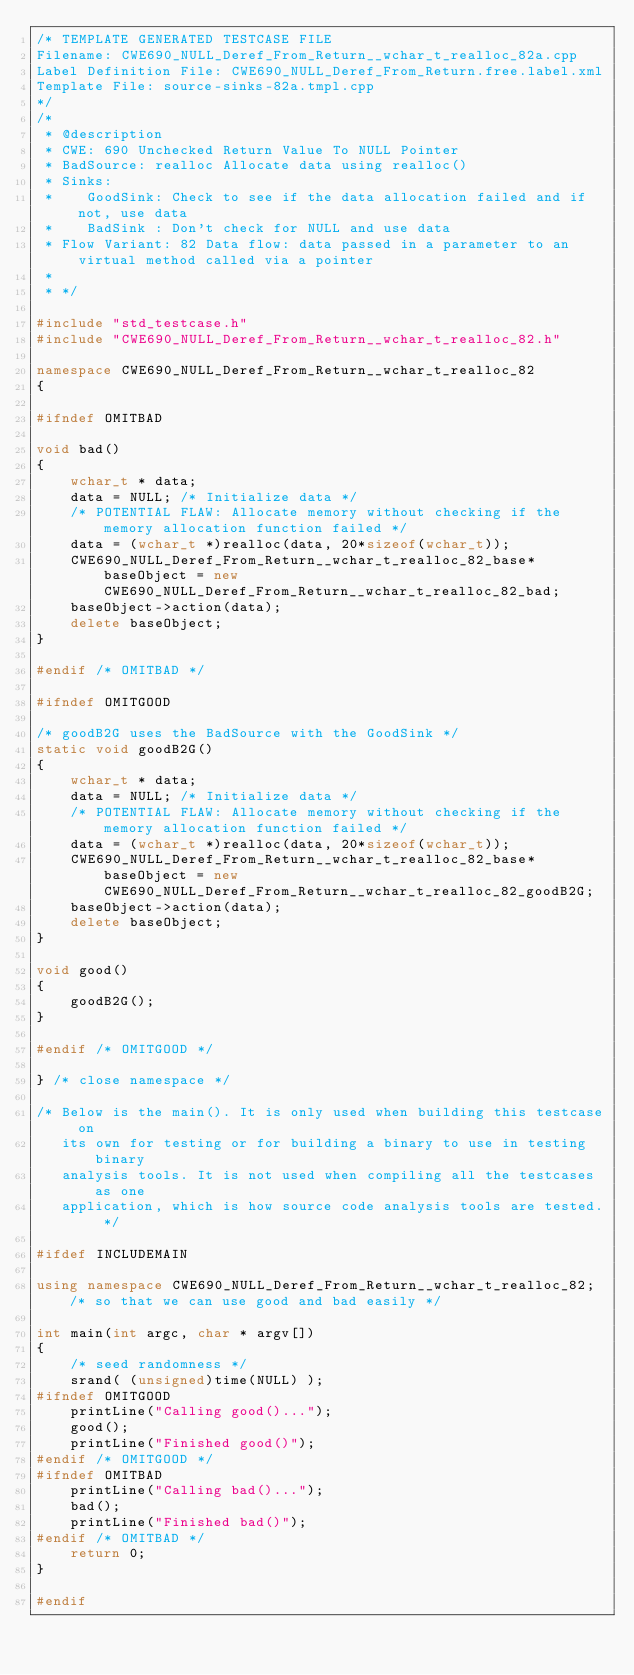<code> <loc_0><loc_0><loc_500><loc_500><_C++_>/* TEMPLATE GENERATED TESTCASE FILE
Filename: CWE690_NULL_Deref_From_Return__wchar_t_realloc_82a.cpp
Label Definition File: CWE690_NULL_Deref_From_Return.free.label.xml
Template File: source-sinks-82a.tmpl.cpp
*/
/*
 * @description
 * CWE: 690 Unchecked Return Value To NULL Pointer
 * BadSource: realloc Allocate data using realloc()
 * Sinks:
 *    GoodSink: Check to see if the data allocation failed and if not, use data
 *    BadSink : Don't check for NULL and use data
 * Flow Variant: 82 Data flow: data passed in a parameter to an virtual method called via a pointer
 *
 * */

#include "std_testcase.h"
#include "CWE690_NULL_Deref_From_Return__wchar_t_realloc_82.h"

namespace CWE690_NULL_Deref_From_Return__wchar_t_realloc_82
{

#ifndef OMITBAD

void bad()
{
    wchar_t * data;
    data = NULL; /* Initialize data */
    /* POTENTIAL FLAW: Allocate memory without checking if the memory allocation function failed */
    data = (wchar_t *)realloc(data, 20*sizeof(wchar_t));
    CWE690_NULL_Deref_From_Return__wchar_t_realloc_82_base* baseObject = new CWE690_NULL_Deref_From_Return__wchar_t_realloc_82_bad;
    baseObject->action(data);
    delete baseObject;
}

#endif /* OMITBAD */

#ifndef OMITGOOD

/* goodB2G uses the BadSource with the GoodSink */
static void goodB2G()
{
    wchar_t * data;
    data = NULL; /* Initialize data */
    /* POTENTIAL FLAW: Allocate memory without checking if the memory allocation function failed */
    data = (wchar_t *)realloc(data, 20*sizeof(wchar_t));
    CWE690_NULL_Deref_From_Return__wchar_t_realloc_82_base* baseObject = new CWE690_NULL_Deref_From_Return__wchar_t_realloc_82_goodB2G;
    baseObject->action(data);
    delete baseObject;
}

void good()
{
    goodB2G();
}

#endif /* OMITGOOD */

} /* close namespace */

/* Below is the main(). It is only used when building this testcase on
   its own for testing or for building a binary to use in testing binary
   analysis tools. It is not used when compiling all the testcases as one
   application, which is how source code analysis tools are tested. */

#ifdef INCLUDEMAIN

using namespace CWE690_NULL_Deref_From_Return__wchar_t_realloc_82; /* so that we can use good and bad easily */

int main(int argc, char * argv[])
{
    /* seed randomness */
    srand( (unsigned)time(NULL) );
#ifndef OMITGOOD
    printLine("Calling good()...");
    good();
    printLine("Finished good()");
#endif /* OMITGOOD */
#ifndef OMITBAD
    printLine("Calling bad()...");
    bad();
    printLine("Finished bad()");
#endif /* OMITBAD */
    return 0;
}

#endif
</code> 